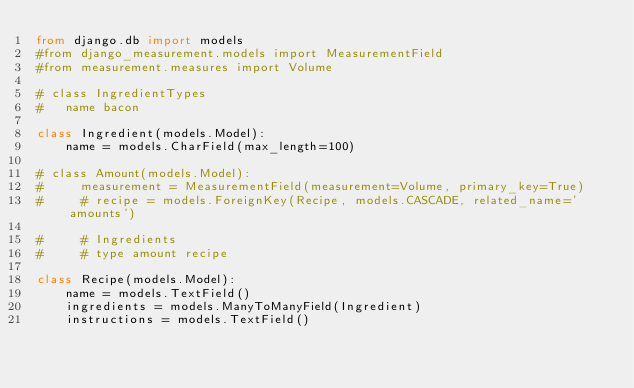Convert code to text. <code><loc_0><loc_0><loc_500><loc_500><_Python_>from django.db import models
#from django_measurement.models import MeasurementField
#from measurement.measures import Volume

# class IngredientTypes
#   name bacon

class Ingredient(models.Model):
    name = models.CharField(max_length=100)

# class Amount(models.Model):
#     measurement = MeasurementField(measurement=Volume, primary_key=True)
#     # recipe = models.ForeignKey(Recipe, models.CASCADE, related_name='amounts')

#     # Ingredients
#     # type amount recipe

class Recipe(models.Model):
    name = models.TextField()
    ingredients = models.ManyToManyField(Ingredient)
    instructions = models.TextField()
</code> 